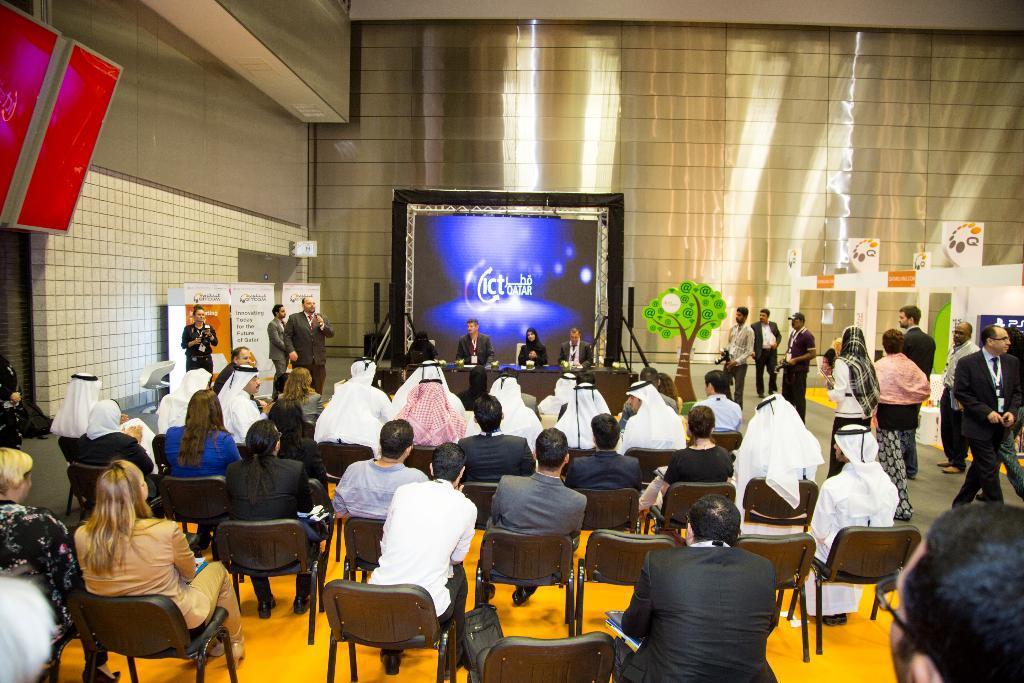Describe this image in one or two sentences. In the picture we can see some people are sitting in the chairs on the floor which is yellow in color and some people are wearing white dresses and in the background we can see some people are sitting on the chairs near the desk and beside it we can see a man standing and talking and on the other side we can see some people are standing holding cameras. 